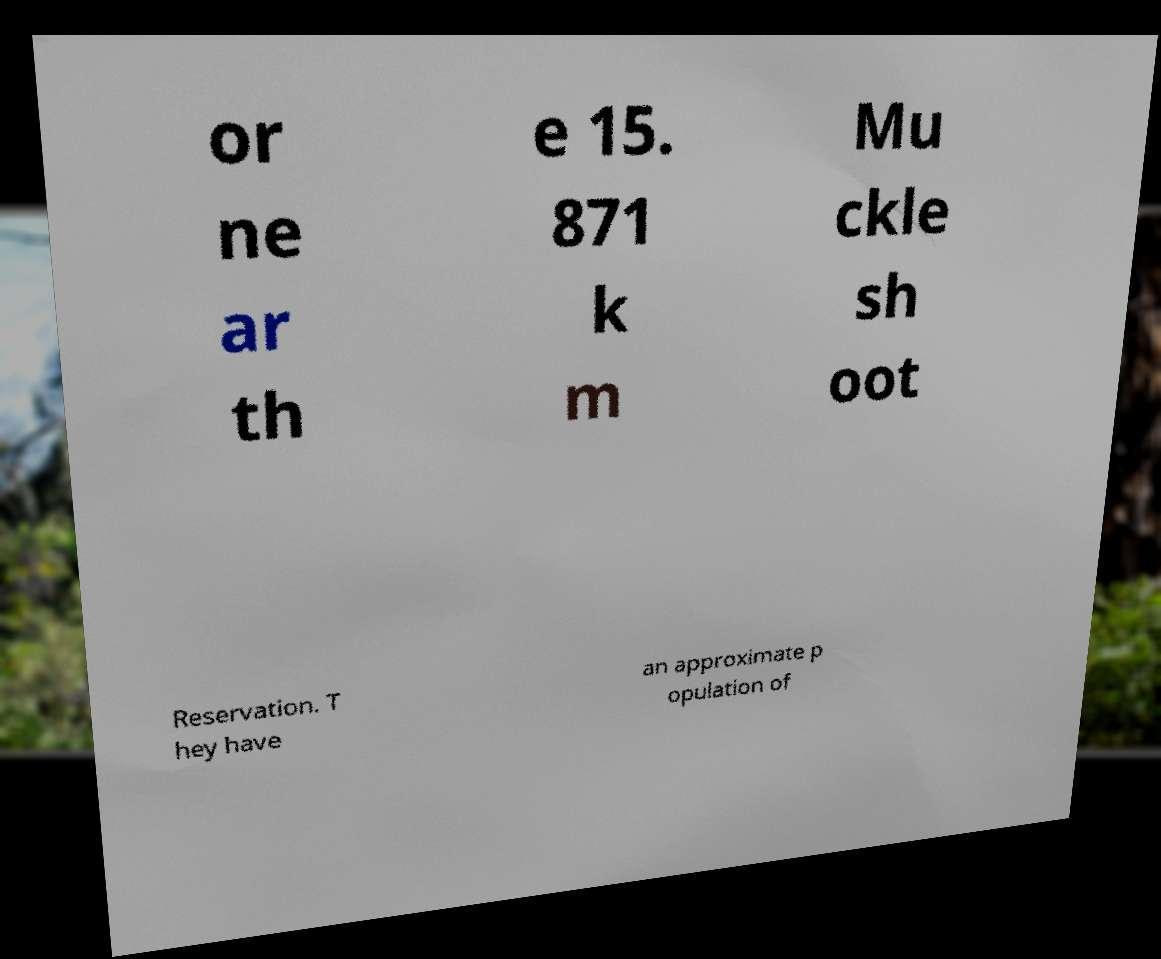Please read and relay the text visible in this image. What does it say? or ne ar th e 15. 871 k m Mu ckle sh oot Reservation. T hey have an approximate p opulation of 